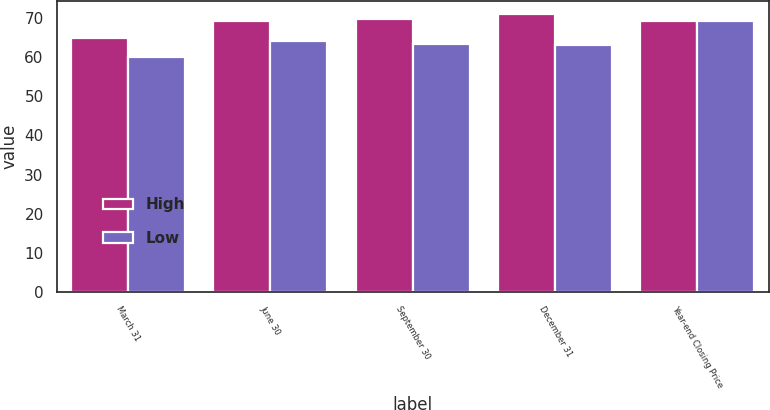Convert chart to OTSL. <chart><loc_0><loc_0><loc_500><loc_500><stacked_bar_chart><ecel><fcel>March 31<fcel>June 30<fcel>September 30<fcel>December 31<fcel>Year-end Closing Price<nl><fcel>High<fcel>65.08<fcel>69.43<fcel>69.79<fcel>71<fcel>69.19<nl><fcel>Low<fcel>60.17<fcel>64.22<fcel>63.4<fcel>63.11<fcel>69.19<nl></chart> 